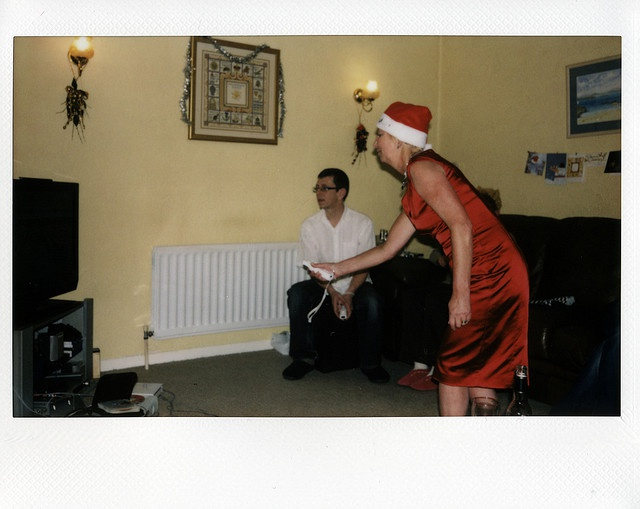Describe the objects in this image and their specific colors. I can see couch in white, black, darkgreen, gray, and maroon tones, people in white, maroon, black, and brown tones, people in white, black, darkgray, and maroon tones, tv in white, black, gray, olive, and darkgreen tones, and bottle in white, black, maroon, gray, and darkgray tones in this image. 